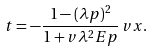<formula> <loc_0><loc_0><loc_500><loc_500>t = - \frac { 1 - ( \lambda p ) ^ { 2 } } { 1 + v \lambda ^ { 2 } E p } \, v x .</formula> 